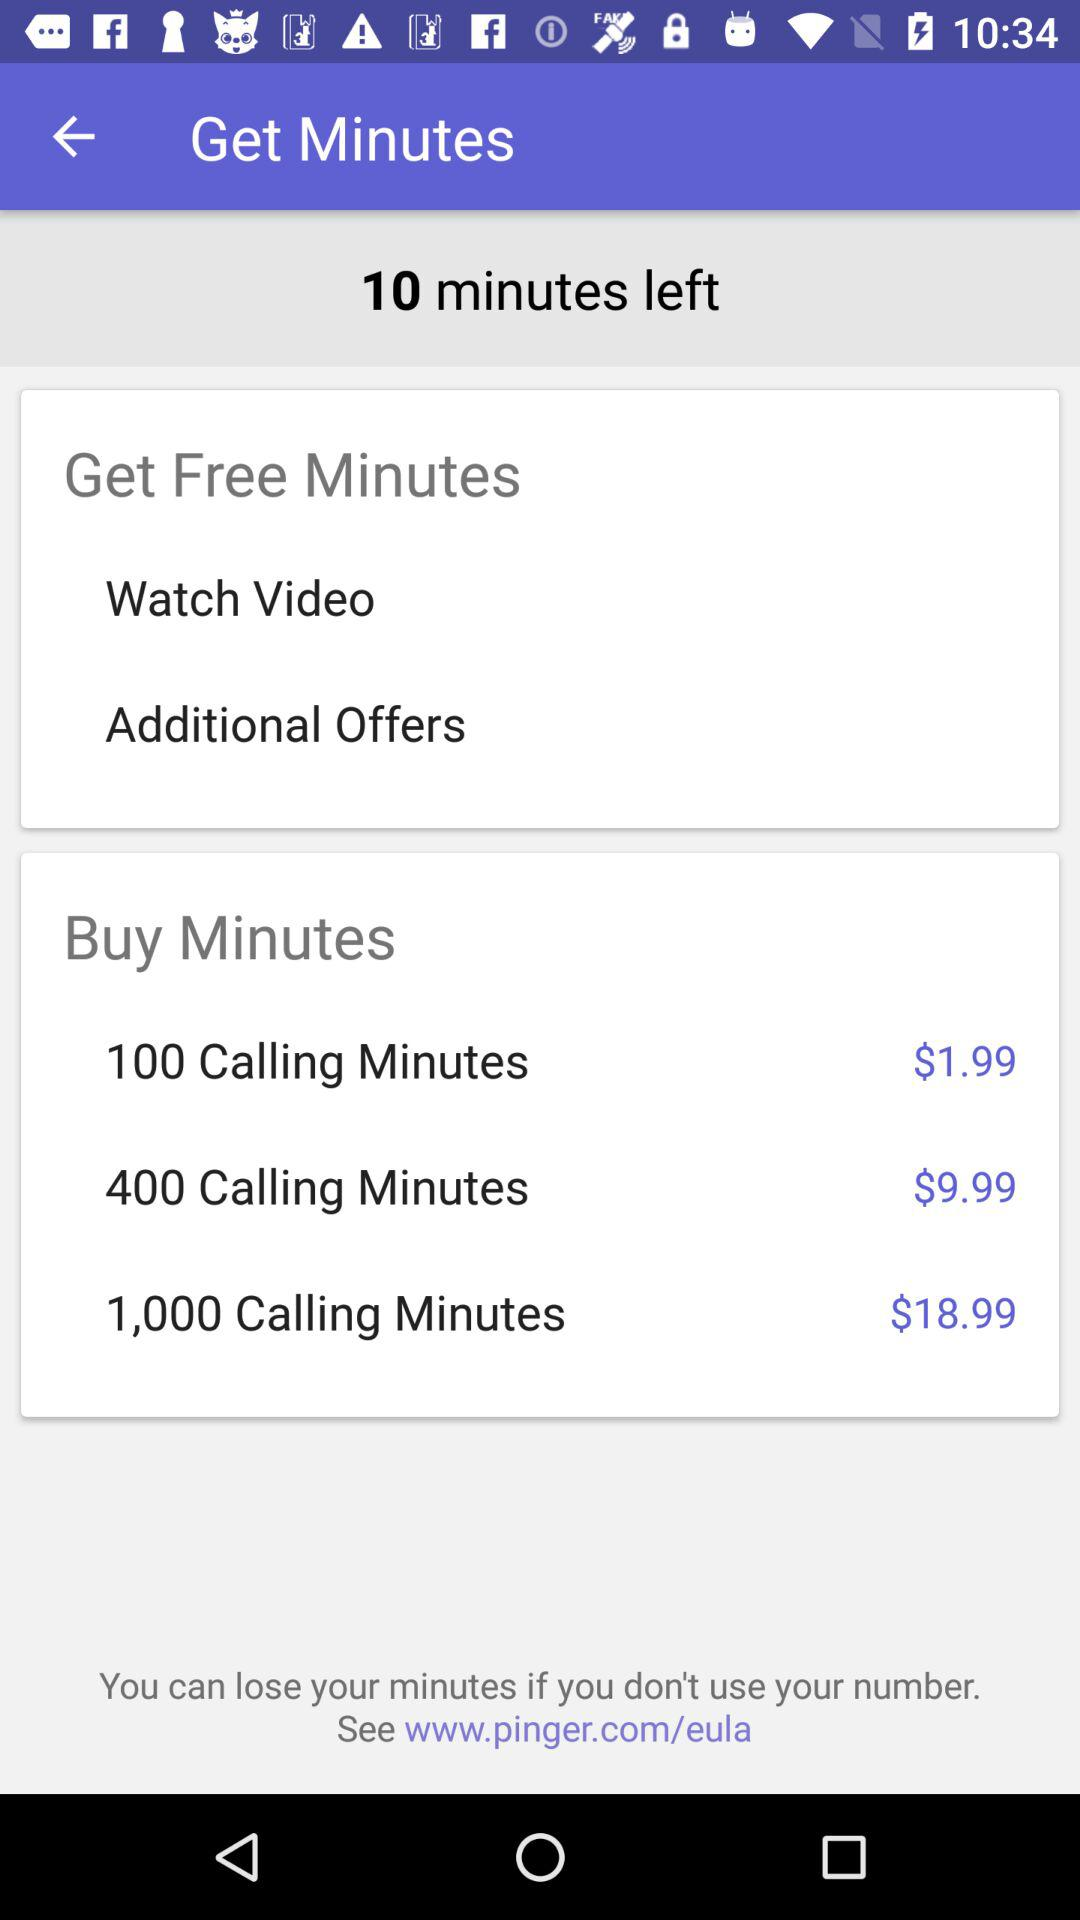What is the price for 100 calling minutes? The price is $1.99. 